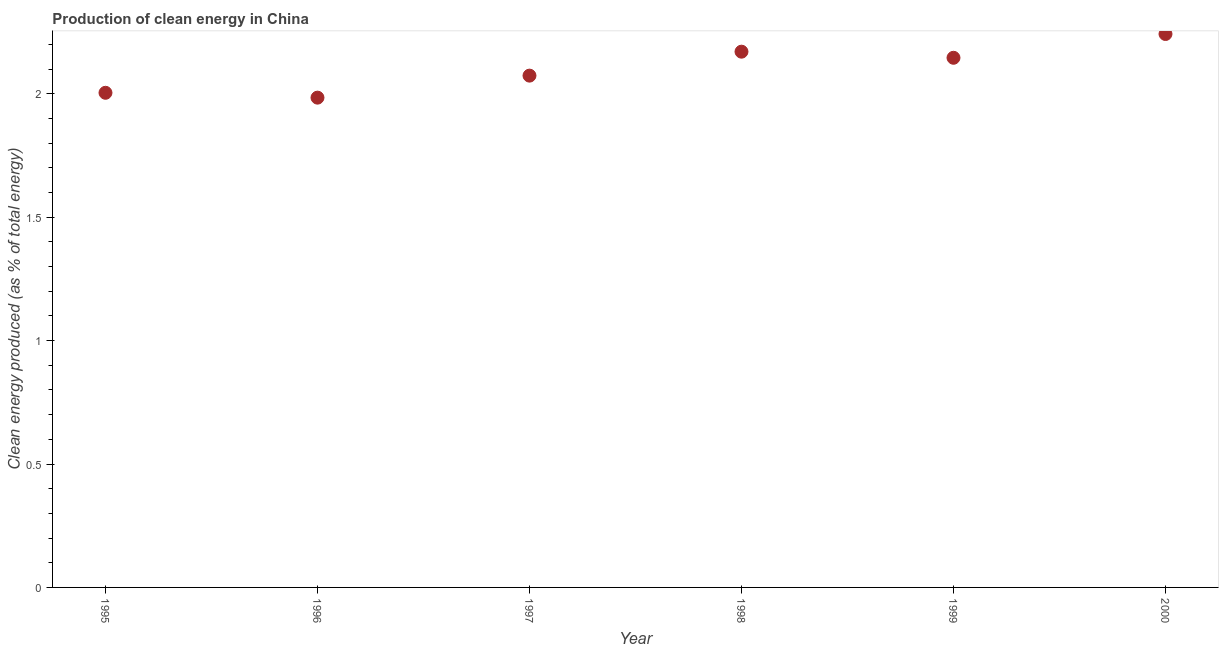What is the production of clean energy in 2000?
Keep it short and to the point. 2.24. Across all years, what is the maximum production of clean energy?
Keep it short and to the point. 2.24. Across all years, what is the minimum production of clean energy?
Your answer should be compact. 1.98. What is the sum of the production of clean energy?
Your answer should be very brief. 12.62. What is the difference between the production of clean energy in 1997 and 2000?
Your answer should be compact. -0.17. What is the average production of clean energy per year?
Offer a very short reply. 2.1. What is the median production of clean energy?
Make the answer very short. 2.11. In how many years, is the production of clean energy greater than 0.2 %?
Your answer should be very brief. 6. Do a majority of the years between 1995 and 1996 (inclusive) have production of clean energy greater than 1.2 %?
Your answer should be very brief. Yes. What is the ratio of the production of clean energy in 1995 to that in 1996?
Your answer should be compact. 1.01. Is the production of clean energy in 1997 less than that in 2000?
Your answer should be compact. Yes. What is the difference between the highest and the second highest production of clean energy?
Offer a very short reply. 0.07. Is the sum of the production of clean energy in 1997 and 1998 greater than the maximum production of clean energy across all years?
Provide a short and direct response. Yes. What is the difference between the highest and the lowest production of clean energy?
Give a very brief answer. 0.26. Does the production of clean energy monotonically increase over the years?
Offer a terse response. No. What is the title of the graph?
Provide a short and direct response. Production of clean energy in China. What is the label or title of the Y-axis?
Ensure brevity in your answer.  Clean energy produced (as % of total energy). What is the Clean energy produced (as % of total energy) in 1995?
Provide a succinct answer. 2. What is the Clean energy produced (as % of total energy) in 1996?
Your response must be concise. 1.98. What is the Clean energy produced (as % of total energy) in 1997?
Offer a terse response. 2.07. What is the Clean energy produced (as % of total energy) in 1998?
Your answer should be very brief. 2.17. What is the Clean energy produced (as % of total energy) in 1999?
Offer a terse response. 2.15. What is the Clean energy produced (as % of total energy) in 2000?
Your answer should be compact. 2.24. What is the difference between the Clean energy produced (as % of total energy) in 1995 and 1996?
Offer a very short reply. 0.02. What is the difference between the Clean energy produced (as % of total energy) in 1995 and 1997?
Your answer should be compact. -0.07. What is the difference between the Clean energy produced (as % of total energy) in 1995 and 1998?
Make the answer very short. -0.17. What is the difference between the Clean energy produced (as % of total energy) in 1995 and 1999?
Your response must be concise. -0.14. What is the difference between the Clean energy produced (as % of total energy) in 1995 and 2000?
Your answer should be compact. -0.24. What is the difference between the Clean energy produced (as % of total energy) in 1996 and 1997?
Offer a very short reply. -0.09. What is the difference between the Clean energy produced (as % of total energy) in 1996 and 1998?
Keep it short and to the point. -0.19. What is the difference between the Clean energy produced (as % of total energy) in 1996 and 1999?
Keep it short and to the point. -0.16. What is the difference between the Clean energy produced (as % of total energy) in 1996 and 2000?
Ensure brevity in your answer.  -0.26. What is the difference between the Clean energy produced (as % of total energy) in 1997 and 1998?
Ensure brevity in your answer.  -0.1. What is the difference between the Clean energy produced (as % of total energy) in 1997 and 1999?
Offer a very short reply. -0.07. What is the difference between the Clean energy produced (as % of total energy) in 1997 and 2000?
Your answer should be very brief. -0.17. What is the difference between the Clean energy produced (as % of total energy) in 1998 and 1999?
Offer a very short reply. 0.02. What is the difference between the Clean energy produced (as % of total energy) in 1998 and 2000?
Your answer should be compact. -0.07. What is the difference between the Clean energy produced (as % of total energy) in 1999 and 2000?
Offer a very short reply. -0.1. What is the ratio of the Clean energy produced (as % of total energy) in 1995 to that in 1996?
Make the answer very short. 1.01. What is the ratio of the Clean energy produced (as % of total energy) in 1995 to that in 1998?
Keep it short and to the point. 0.92. What is the ratio of the Clean energy produced (as % of total energy) in 1995 to that in 1999?
Offer a very short reply. 0.93. What is the ratio of the Clean energy produced (as % of total energy) in 1995 to that in 2000?
Your answer should be very brief. 0.89. What is the ratio of the Clean energy produced (as % of total energy) in 1996 to that in 1998?
Provide a succinct answer. 0.91. What is the ratio of the Clean energy produced (as % of total energy) in 1996 to that in 1999?
Your answer should be very brief. 0.93. What is the ratio of the Clean energy produced (as % of total energy) in 1996 to that in 2000?
Your response must be concise. 0.89. What is the ratio of the Clean energy produced (as % of total energy) in 1997 to that in 1998?
Provide a short and direct response. 0.95. What is the ratio of the Clean energy produced (as % of total energy) in 1997 to that in 1999?
Your answer should be compact. 0.97. What is the ratio of the Clean energy produced (as % of total energy) in 1997 to that in 2000?
Provide a succinct answer. 0.93. What is the ratio of the Clean energy produced (as % of total energy) in 1998 to that in 1999?
Your answer should be very brief. 1.01. What is the ratio of the Clean energy produced (as % of total energy) in 1999 to that in 2000?
Ensure brevity in your answer.  0.96. 